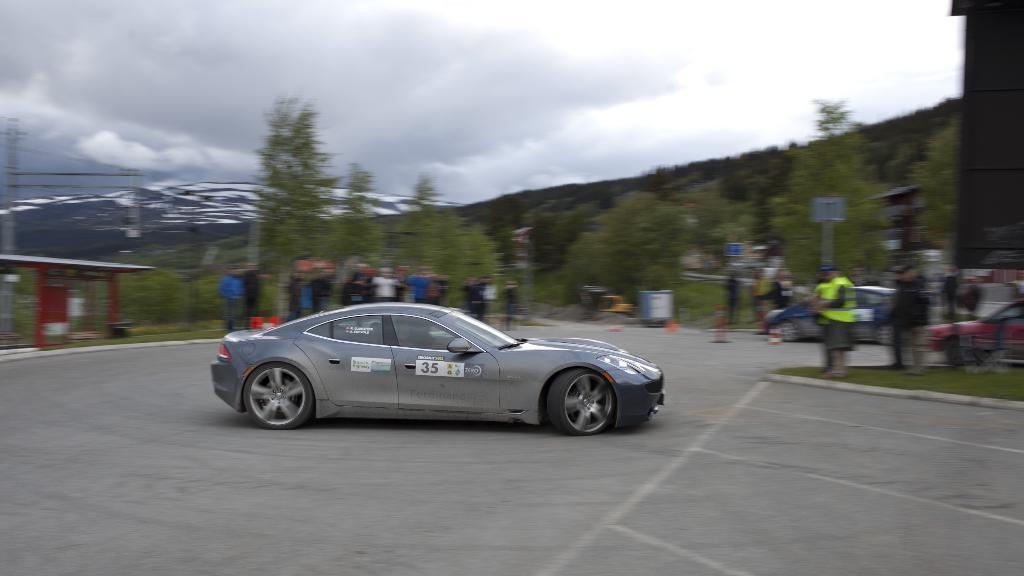How would you summarize this image in a sentence or two? In this image, there are a few vehicles and people. We can also see the ground with some objects. We can see some poles with boards. We can also see a red colored object on the left and a black colored object on the right. There are a few trees, towers. We can also see some wires. We can see some hills and the sky with clouds. 